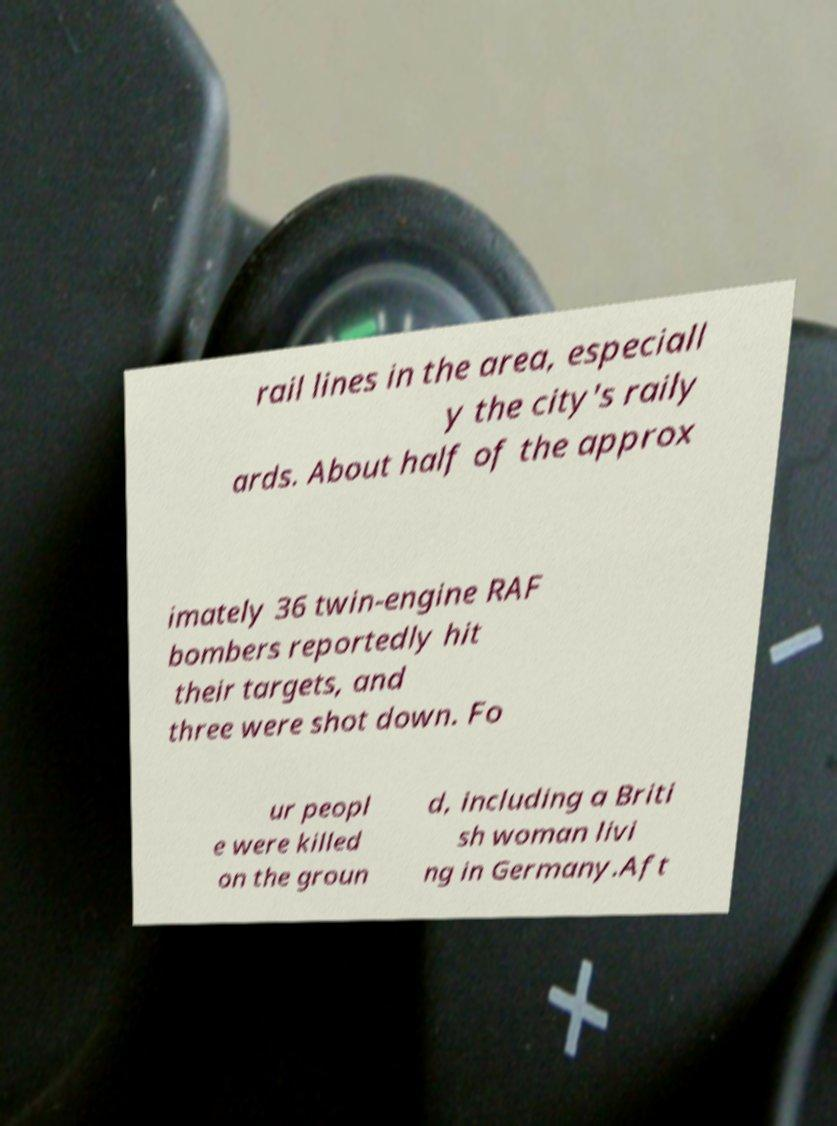Could you assist in decoding the text presented in this image and type it out clearly? rail lines in the area, especiall y the city's raily ards. About half of the approx imately 36 twin-engine RAF bombers reportedly hit their targets, and three were shot down. Fo ur peopl e were killed on the groun d, including a Briti sh woman livi ng in Germany.Aft 